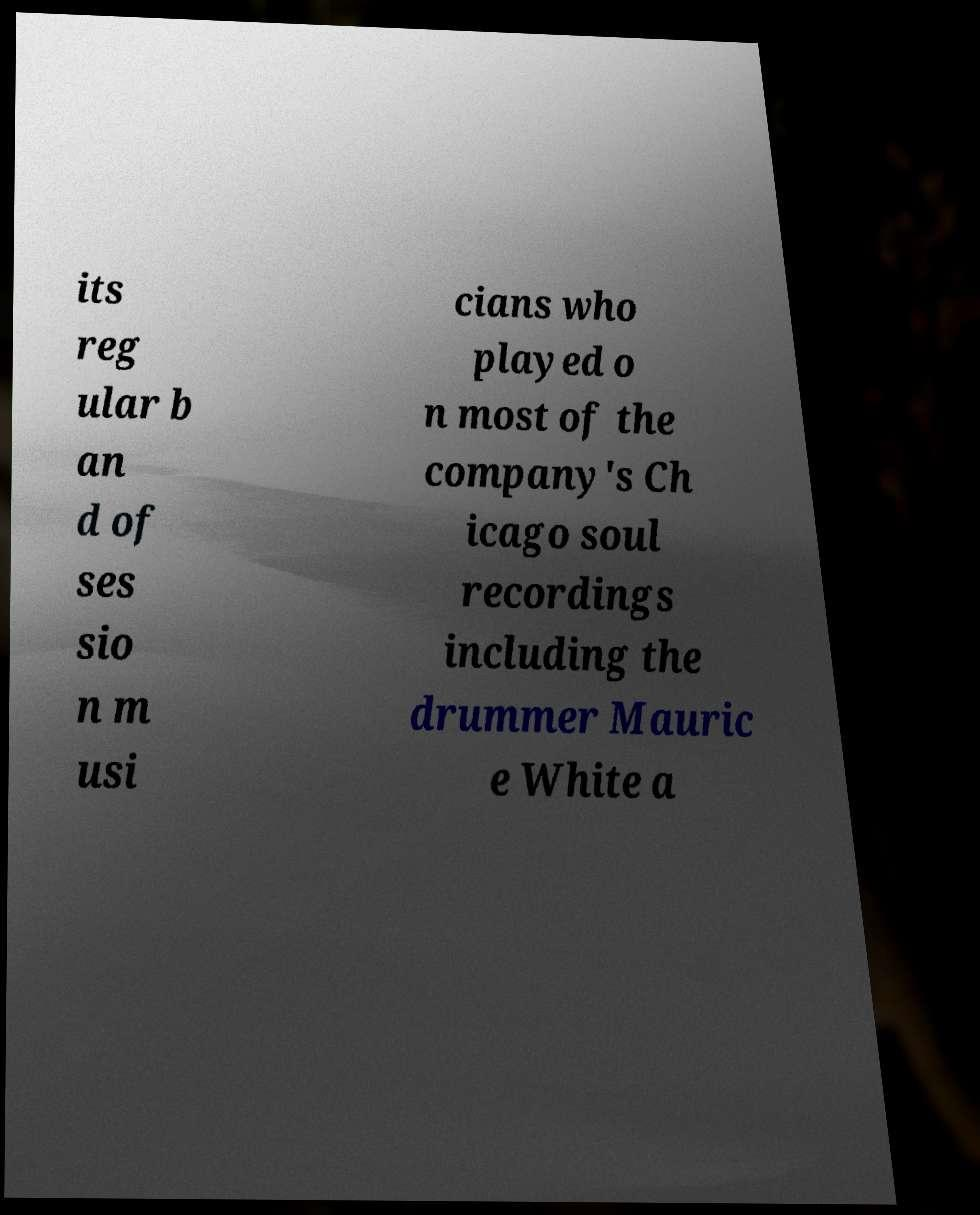Can you accurately transcribe the text from the provided image for me? its reg ular b an d of ses sio n m usi cians who played o n most of the company's Ch icago soul recordings including the drummer Mauric e White a 